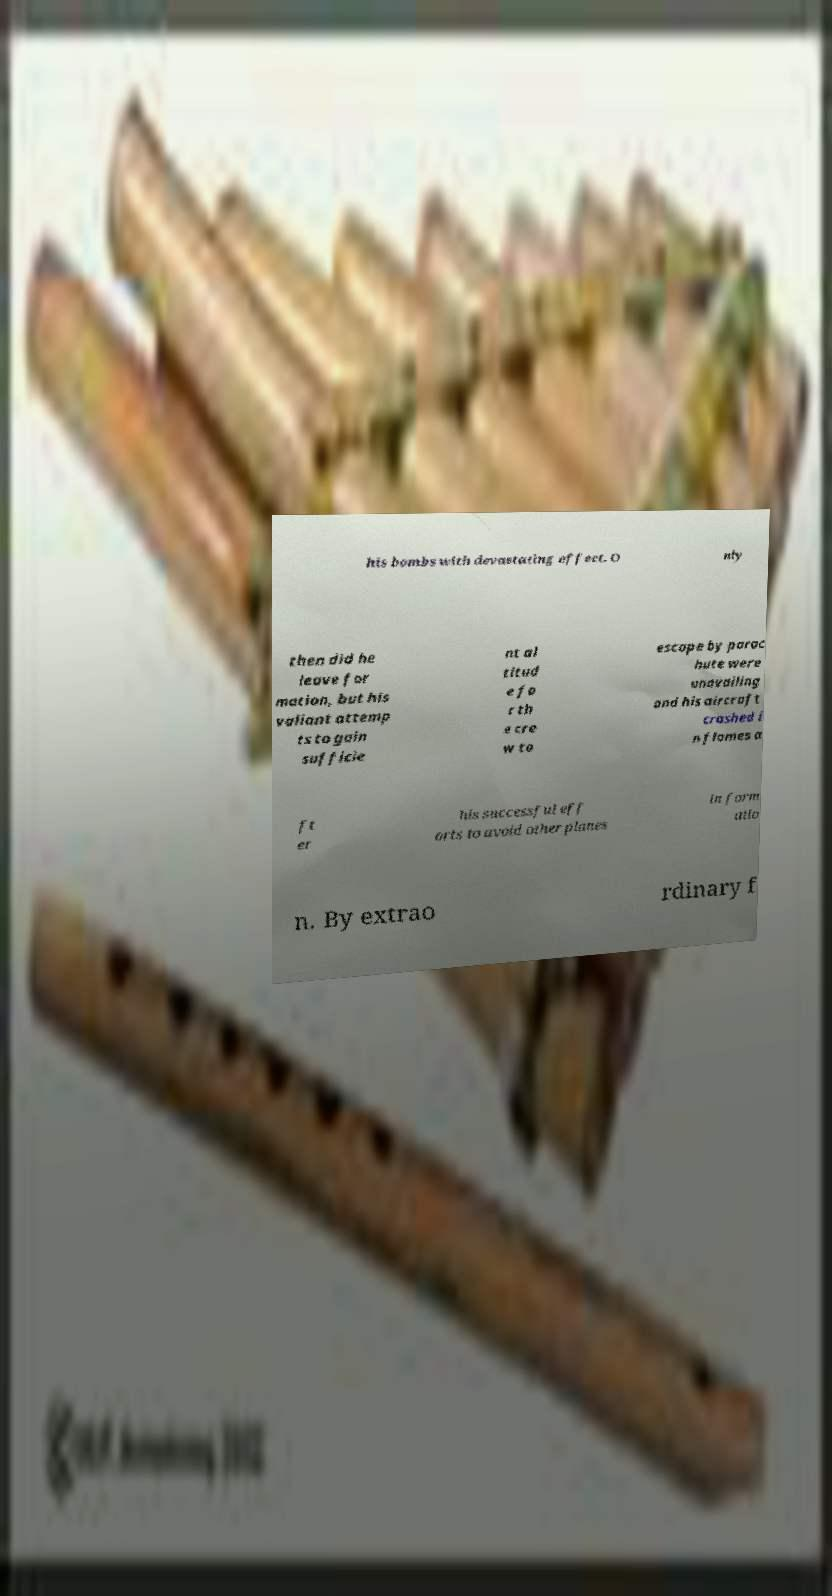Can you accurately transcribe the text from the provided image for me? his bombs with devastating effect. O nly then did he leave for mation, but his valiant attemp ts to gain sufficie nt al titud e fo r th e cre w to escape by parac hute were unavailing and his aircraft crashed i n flames a ft er his successful eff orts to avoid other planes in form atio n. By extrao rdinary f 